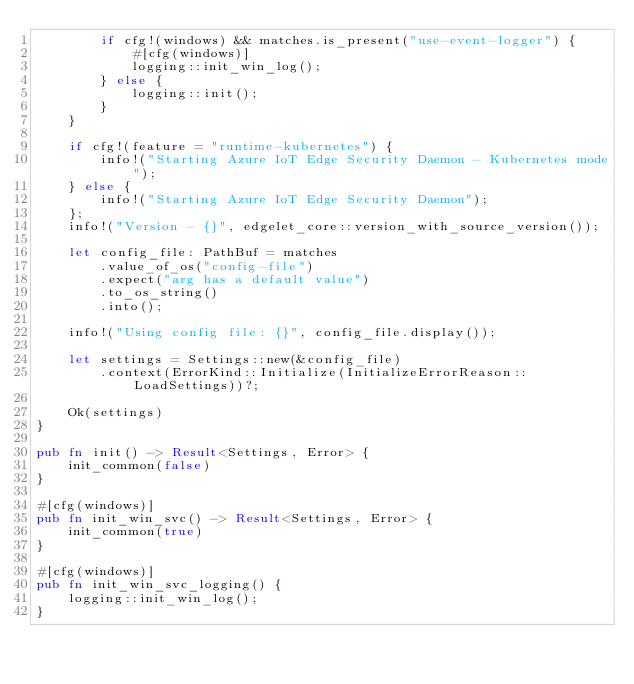<code> <loc_0><loc_0><loc_500><loc_500><_Rust_>        if cfg!(windows) && matches.is_present("use-event-logger") {
            #[cfg(windows)]
            logging::init_win_log();
        } else {
            logging::init();
        }
    }

    if cfg!(feature = "runtime-kubernetes") {
        info!("Starting Azure IoT Edge Security Daemon - Kubernetes mode");
    } else {
        info!("Starting Azure IoT Edge Security Daemon");
    };
    info!("Version - {}", edgelet_core::version_with_source_version());

    let config_file: PathBuf = matches
        .value_of_os("config-file")
        .expect("arg has a default value")
        .to_os_string()
        .into();

    info!("Using config file: {}", config_file.display());

    let settings = Settings::new(&config_file)
        .context(ErrorKind::Initialize(InitializeErrorReason::LoadSettings))?;

    Ok(settings)
}

pub fn init() -> Result<Settings, Error> {
    init_common(false)
}

#[cfg(windows)]
pub fn init_win_svc() -> Result<Settings, Error> {
    init_common(true)
}

#[cfg(windows)]
pub fn init_win_svc_logging() {
    logging::init_win_log();
}
</code> 